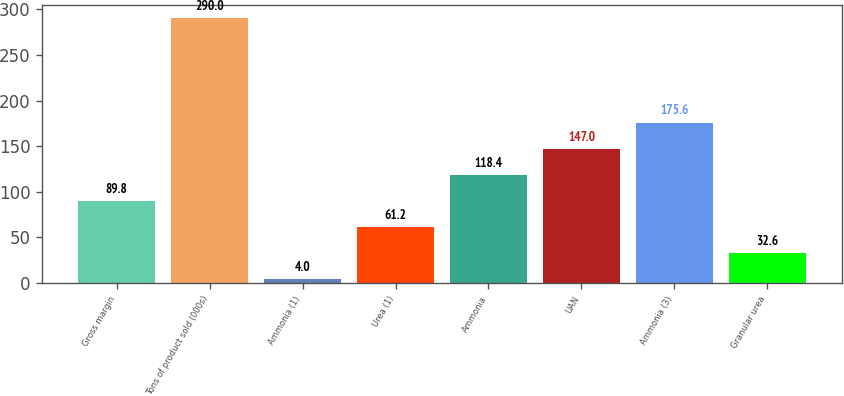Convert chart. <chart><loc_0><loc_0><loc_500><loc_500><bar_chart><fcel>Gross margin<fcel>Tons of product sold (000s)<fcel>Ammonia (1)<fcel>Urea (1)<fcel>Ammonia<fcel>UAN<fcel>Ammonia (3)<fcel>Granular urea<nl><fcel>89.8<fcel>290<fcel>4<fcel>61.2<fcel>118.4<fcel>147<fcel>175.6<fcel>32.6<nl></chart> 